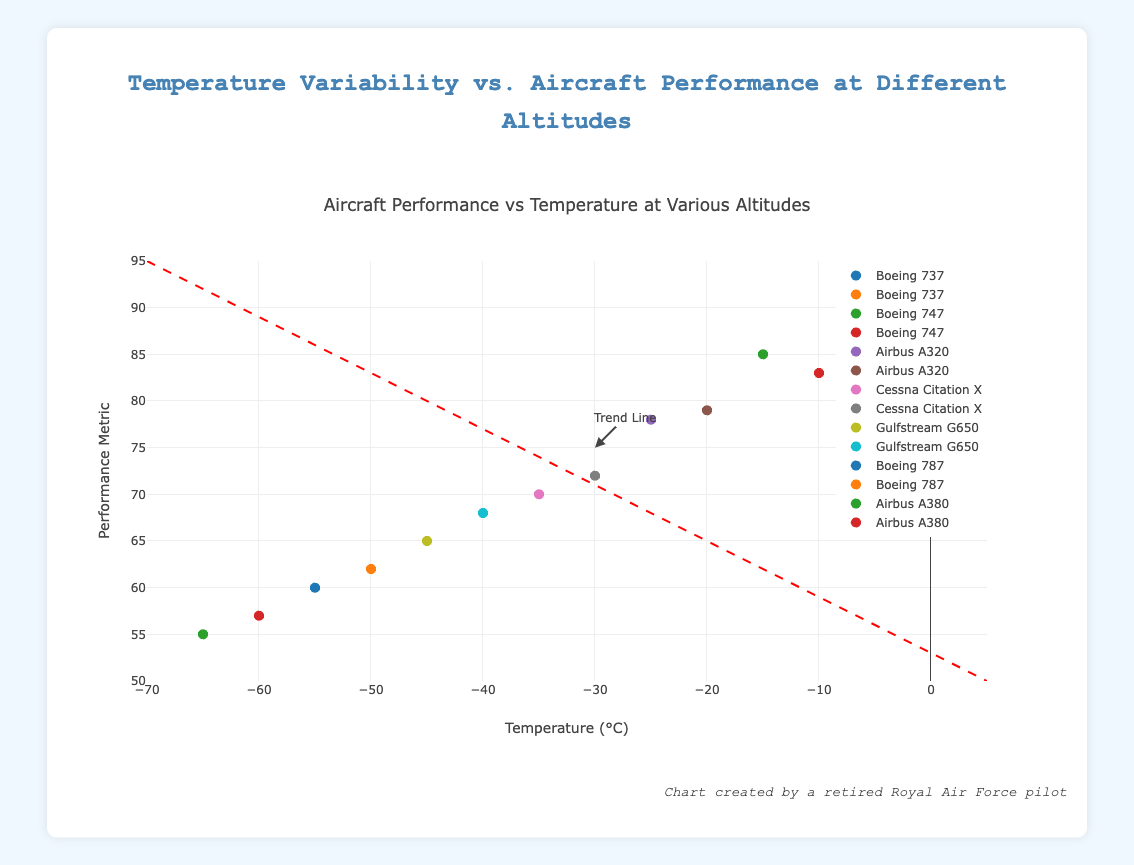What is the title of the figure? The title is usually at the top of the figure in larger font to describe what the plot is about. In this case, it is "Aircraft Performance vs Temperature at Various Altitudes"
Answer: Aircraft Performance vs Temperature at Various Altitudes What is the name of the aircraft performing best at 5000 feet? From the markers and hover text, we can see the aircraft types at specific altitudes and performance metrics. At 5000 feet, the Boeing 737 shows the highest performance metric.
Answer: Boeing 737 How does the performance metric change as the temperature decreases, according to the trend line? The trend line shows the overall direction of data points. As the temperature decreases (moves left on the x-axis), the performance metric also decreases (moves down on the y-axis). This is confirmed by the downward slope of the trend line.
Answer: Decreases What is the maximum performance metric observed, and for which aircraft at what altitude? By looking at the y-axis and the highest point on the graph, the maximum performance metric is 92 for the Boeing 737 at 5000 feet.
Answer: 92, Boeing 737 at 5000 feet What is the trend line annotation meant to indicate? The annotation with text "Trend Line" and an arrow pointing to the trend line is meant to highlight the overall direction of the data points on the plot. It shows the negative relationship between temperature and performance metric.
Answer: Trend Line 